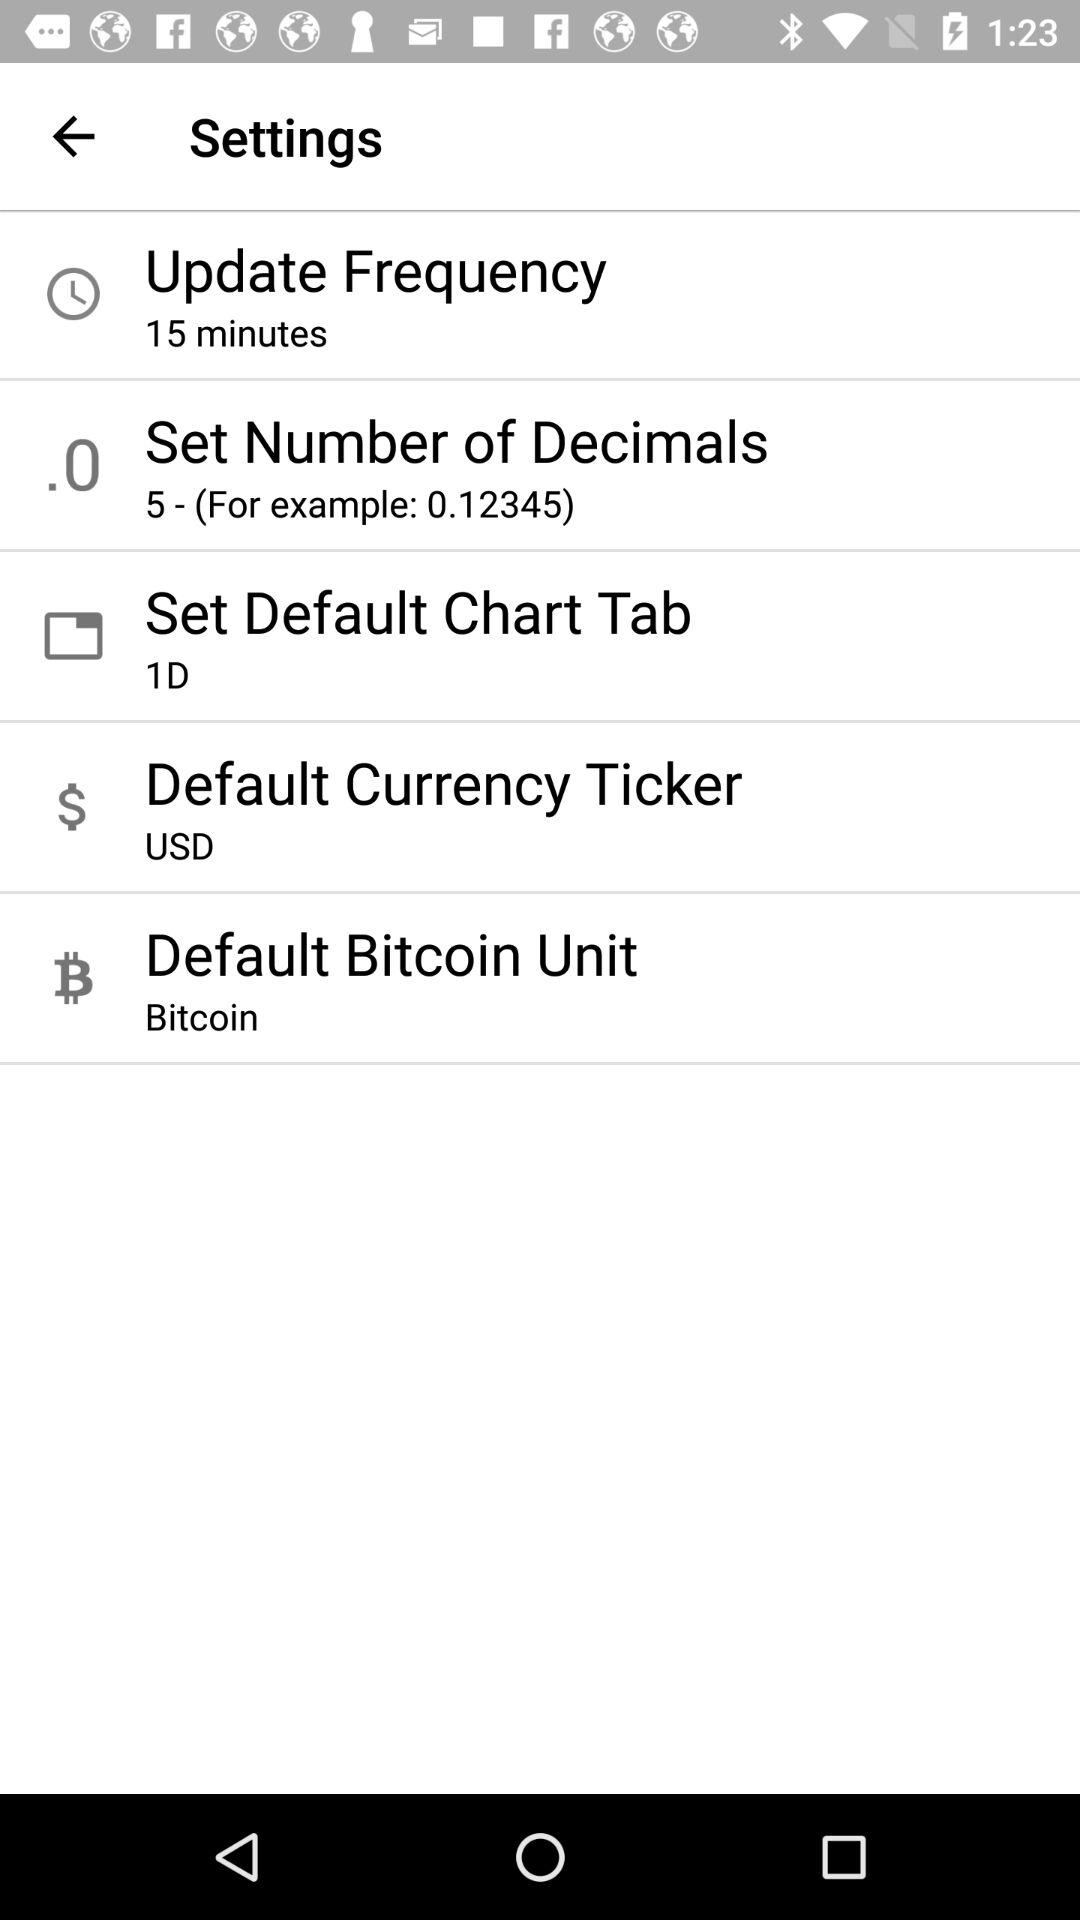What's the default Bitcoin unit? The default Bitcoin unit is "Bitcoin". 